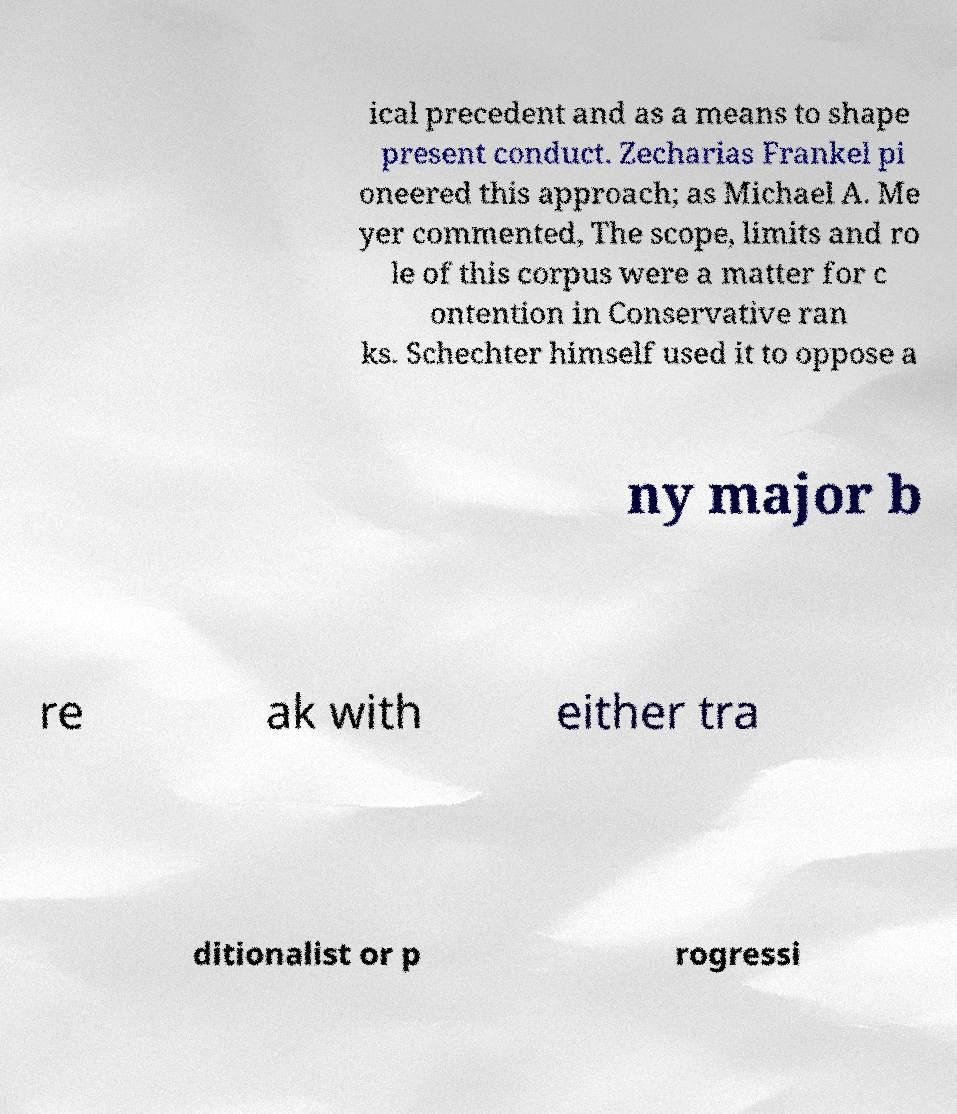Can you read and provide the text displayed in the image?This photo seems to have some interesting text. Can you extract and type it out for me? ical precedent and as a means to shape present conduct. Zecharias Frankel pi oneered this approach; as Michael A. Me yer commented, The scope, limits and ro le of this corpus were a matter for c ontention in Conservative ran ks. Schechter himself used it to oppose a ny major b re ak with either tra ditionalist or p rogressi 